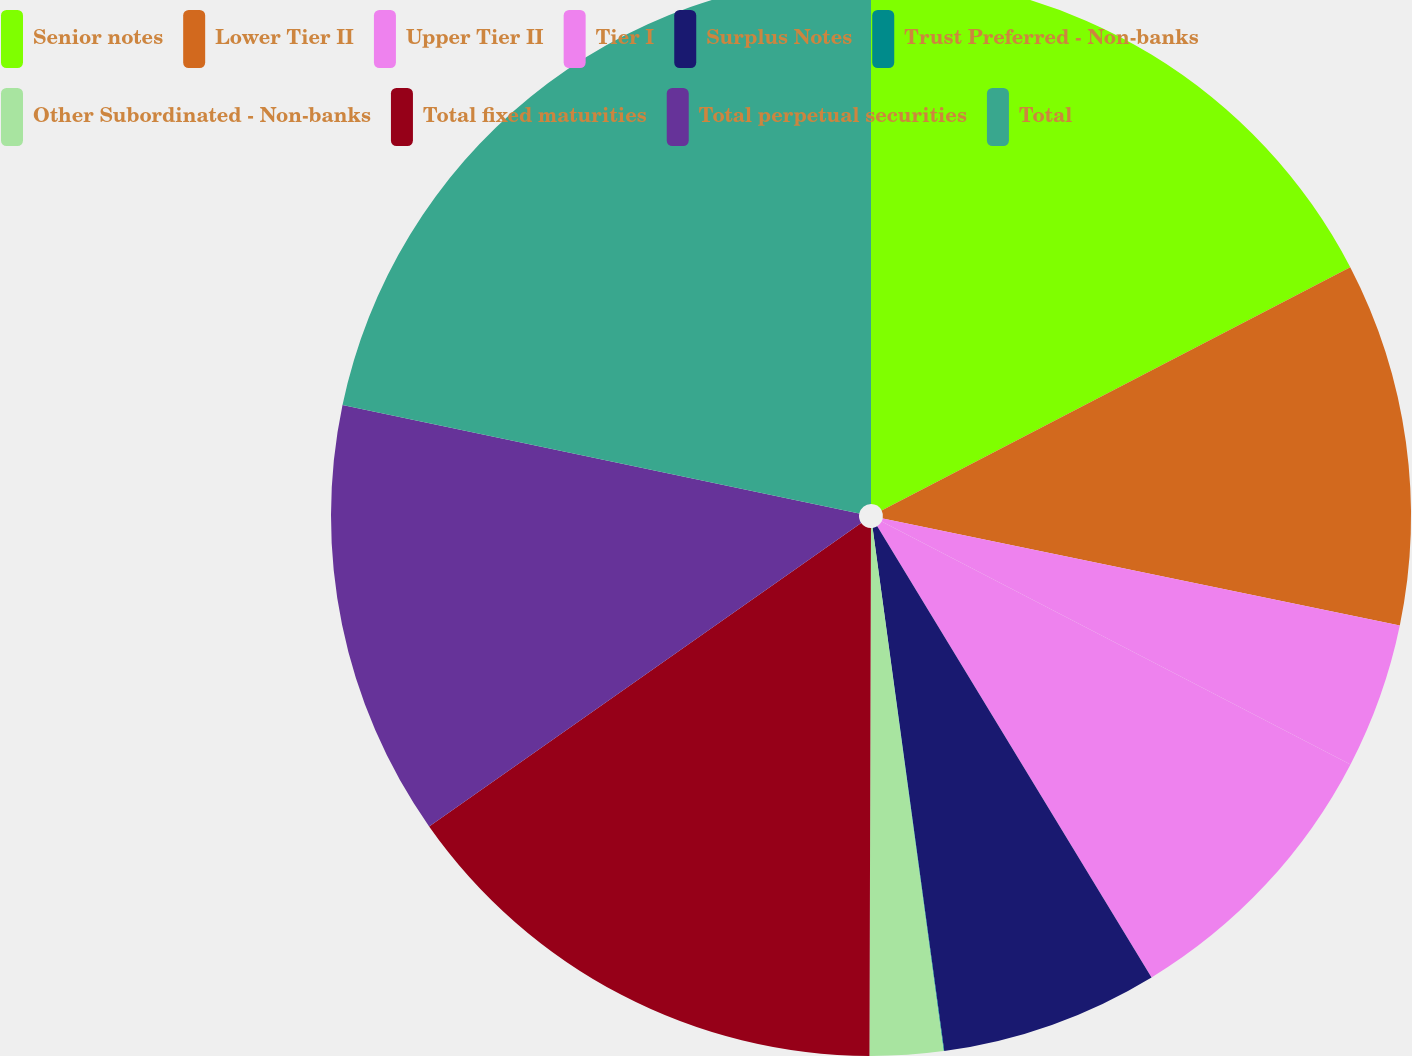Convert chart to OTSL. <chart><loc_0><loc_0><loc_500><loc_500><pie_chart><fcel>Senior notes<fcel>Lower Tier II<fcel>Upper Tier II<fcel>Tier I<fcel>Surplus Notes<fcel>Trust Preferred - Non-banks<fcel>Other Subordinated - Non-banks<fcel>Total fixed maturities<fcel>Total perpetual securities<fcel>Total<nl><fcel>17.38%<fcel>10.87%<fcel>4.36%<fcel>8.7%<fcel>6.53%<fcel>0.02%<fcel>2.19%<fcel>15.21%<fcel>13.04%<fcel>21.71%<nl></chart> 